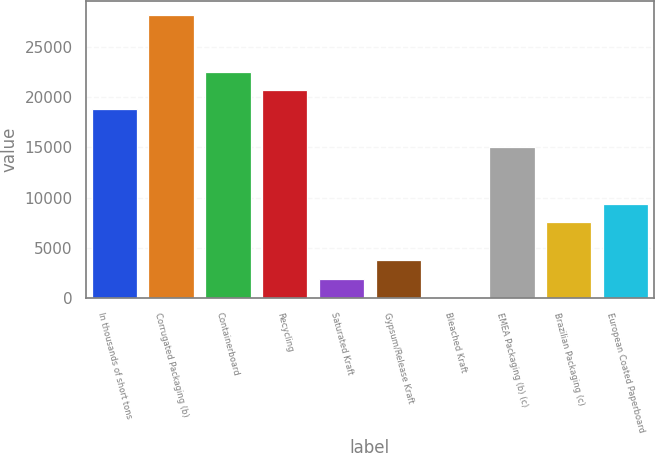<chart> <loc_0><loc_0><loc_500><loc_500><bar_chart><fcel>In thousands of short tons<fcel>Corrugated Packaging (b)<fcel>Containerboard<fcel>Recycling<fcel>Saturated Kraft<fcel>Gypsum/Release Kraft<fcel>Bleached Kraft<fcel>EMEA Packaging (b) (c)<fcel>Brazilian Packaging (c)<fcel>European Coated Paperboard<nl><fcel>18806<fcel>28193.5<fcel>22561<fcel>20683.5<fcel>1908.5<fcel>3786<fcel>31<fcel>15051<fcel>7541<fcel>9418.5<nl></chart> 